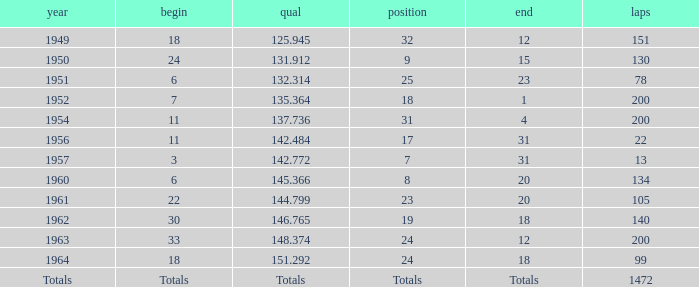Name the finish with Laps more than 200 Totals. Give me the full table as a dictionary. {'header': ['year', 'begin', 'qual', 'position', 'end', 'laps'], 'rows': [['1949', '18', '125.945', '32', '12', '151'], ['1950', '24', '131.912', '9', '15', '130'], ['1951', '6', '132.314', '25', '23', '78'], ['1952', '7', '135.364', '18', '1', '200'], ['1954', '11', '137.736', '31', '4', '200'], ['1956', '11', '142.484', '17', '31', '22'], ['1957', '3', '142.772', '7', '31', '13'], ['1960', '6', '145.366', '8', '20', '134'], ['1961', '22', '144.799', '23', '20', '105'], ['1962', '30', '146.765', '19', '18', '140'], ['1963', '33', '148.374', '24', '12', '200'], ['1964', '18', '151.292', '24', '18', '99'], ['Totals', 'Totals', 'Totals', 'Totals', 'Totals', '1472']]} 